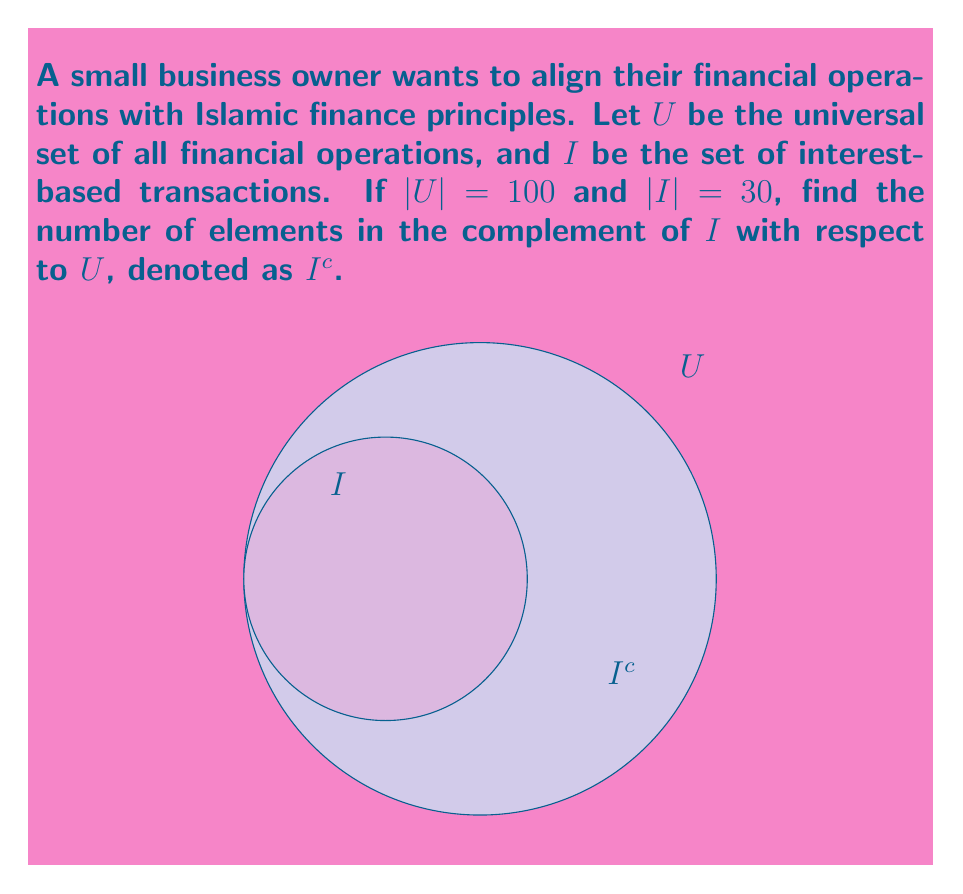Give your solution to this math problem. Let's approach this step-by-step:

1) The complement of a set $A$ with respect to the universal set $U$ is defined as all elements in $U$ that are not in $A$. In set notation, this is written as:

   $A^c = U \setminus A = \{x \in U | x \notin A\}$

2) In this case, we're looking for $I^c$, which represents all financial operations that are not interest-based.

3) To find the number of elements in $I^c$, we can use the following property:

   $|I^c| = |U| - |I|$

4) We're given that:
   $|U| = 100$ (total number of financial operations)
   $|I| = 30$ (number of interest-based transactions)

5) Substituting these values into our equation:

   $|I^c| = 100 - 30 = 70$

Therefore, there are 70 financial operations that are not interest-based.
Answer: $|I^c| = 70$ 